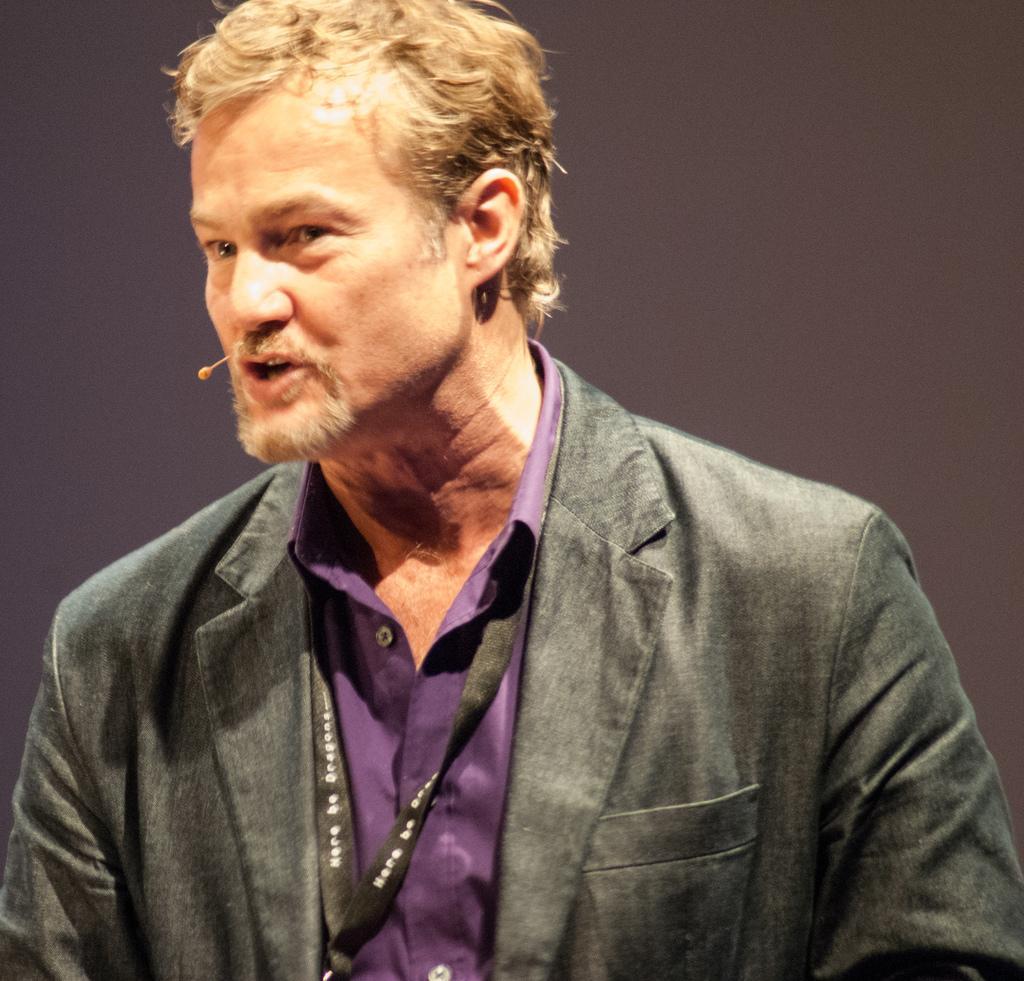In one or two sentences, can you explain what this image depicts? In the image I can see a person who is wearing the suit and a tag. 